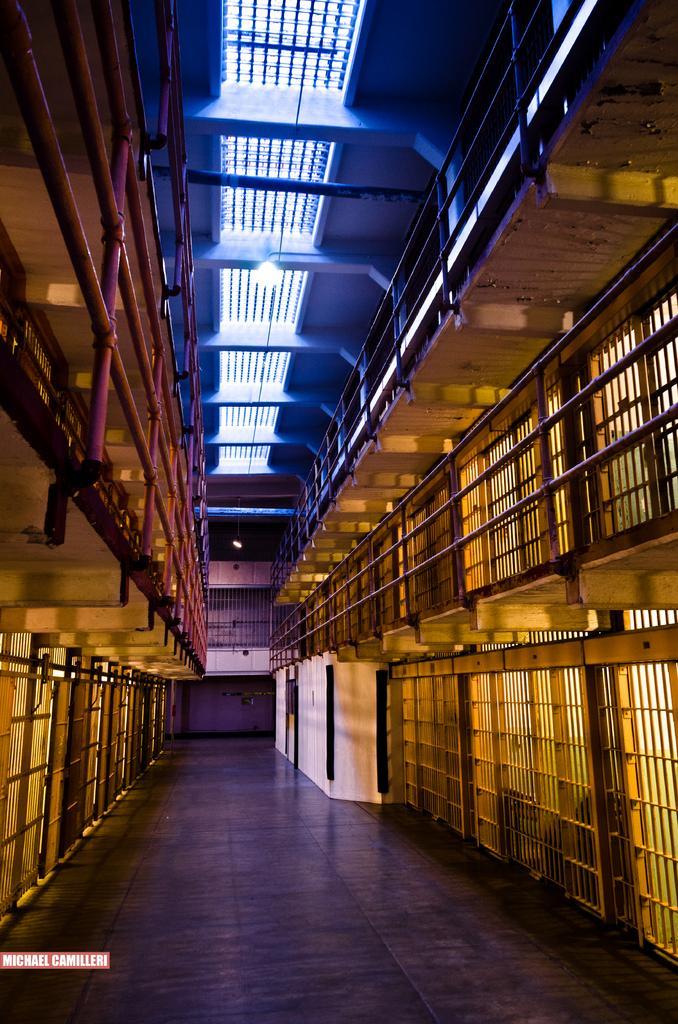Could you give a brief overview of what you see in this image? This is the picture of a building. At the top there are pipes and there is a railing and there are lights. At the bottom there is a floor. 